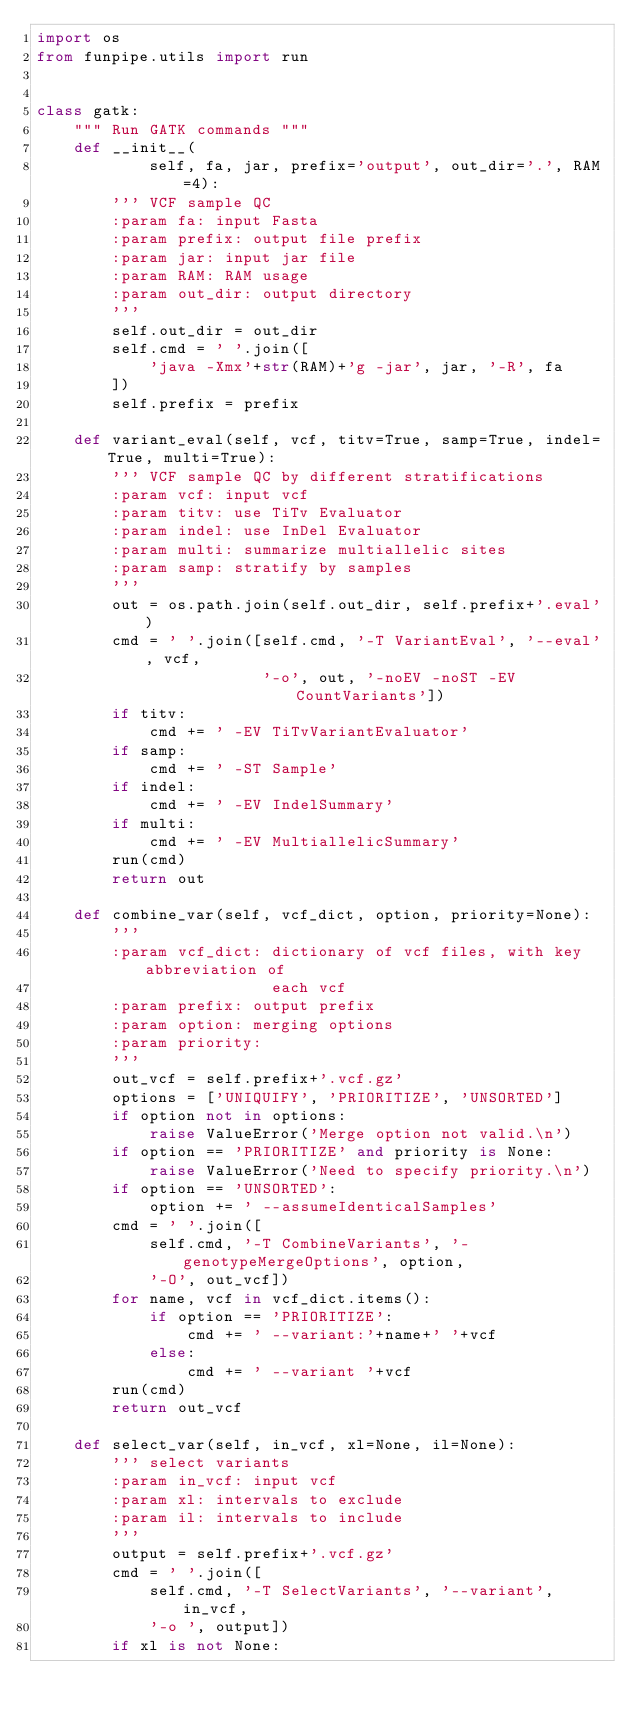<code> <loc_0><loc_0><loc_500><loc_500><_Python_>import os
from funpipe.utils import run


class gatk:
    """ Run GATK commands """
    def __init__(
            self, fa, jar, prefix='output', out_dir='.', RAM=4):
        ''' VCF sample QC
        :param fa: input Fasta
        :param prefix: output file prefix
        :param jar: input jar file
        :param RAM: RAM usage
        :param out_dir: output directory
        '''
        self.out_dir = out_dir
        self.cmd = ' '.join([
            'java -Xmx'+str(RAM)+'g -jar', jar, '-R', fa
        ])
        self.prefix = prefix

    def variant_eval(self, vcf, titv=True, samp=True, indel=True, multi=True):
        ''' VCF sample QC by different stratifications
        :param vcf: input vcf
        :param titv: use TiTv Evaluator
        :param indel: use InDel Evaluator
        :param multi: summarize multiallelic sites
        :param samp: stratify by samples
        '''
        out = os.path.join(self.out_dir, self.prefix+'.eval')
        cmd = ' '.join([self.cmd, '-T VariantEval', '--eval', vcf,
                        '-o', out, '-noEV -noST -EV CountVariants'])
        if titv:
            cmd += ' -EV TiTvVariantEvaluator'
        if samp:
            cmd += ' -ST Sample'
        if indel:
            cmd += ' -EV IndelSummary'
        if multi:
            cmd += ' -EV MultiallelicSummary'
        run(cmd)
        return out

    def combine_var(self, vcf_dict, option, priority=None):
        '''
        :param vcf_dict: dictionary of vcf files, with key abbreviation of
                         each vcf
        :param prefix: output prefix
        :param option: merging options
        :param priority:
        '''
        out_vcf = self.prefix+'.vcf.gz'
        options = ['UNIQUIFY', 'PRIORITIZE', 'UNSORTED']
        if option not in options:
            raise ValueError('Merge option not valid.\n')
        if option == 'PRIORITIZE' and priority is None:
            raise ValueError('Need to specify priority.\n')
        if option == 'UNSORTED':
            option += ' --assumeIdenticalSamples'
        cmd = ' '.join([
            self.cmd, '-T CombineVariants', '-genotypeMergeOptions', option,
            '-O', out_vcf])
        for name, vcf in vcf_dict.items():
            if option == 'PRIORITIZE':
                cmd += ' --variant:'+name+' '+vcf
            else:
                cmd += ' --variant '+vcf
        run(cmd)
        return out_vcf

    def select_var(self, in_vcf, xl=None, il=None):
        ''' select variants
        :param in_vcf: input vcf
        :param xl: intervals to exclude
        :param il: intervals to include
        '''
        output = self.prefix+'.vcf.gz'
        cmd = ' '.join([
            self.cmd, '-T SelectVariants', '--variant', in_vcf,
            '-o ', output])
        if xl is not None:</code> 